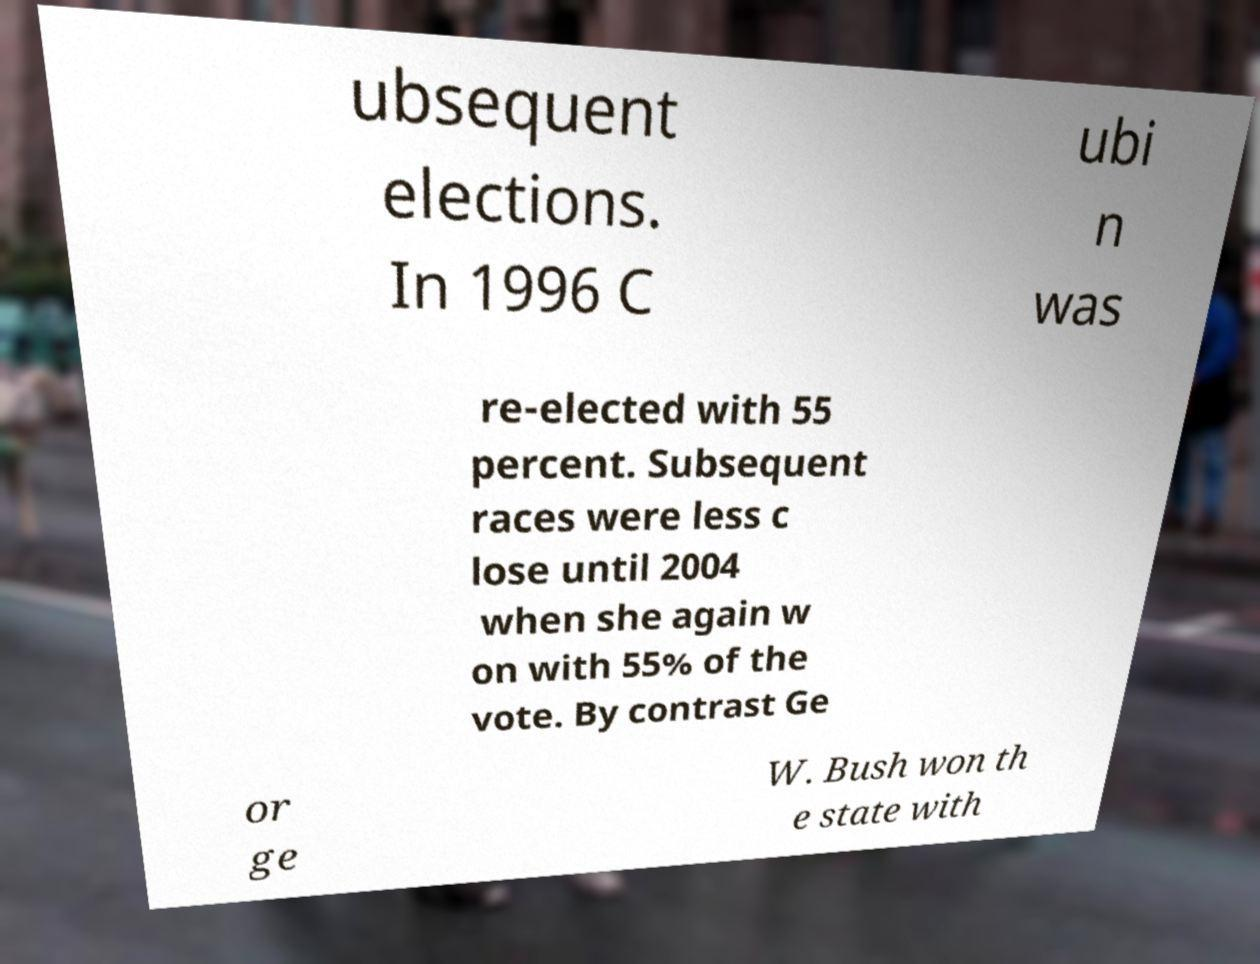Could you extract and type out the text from this image? ubsequent elections. In 1996 C ubi n was re-elected with 55 percent. Subsequent races were less c lose until 2004 when she again w on with 55% of the vote. By contrast Ge or ge W. Bush won th e state with 